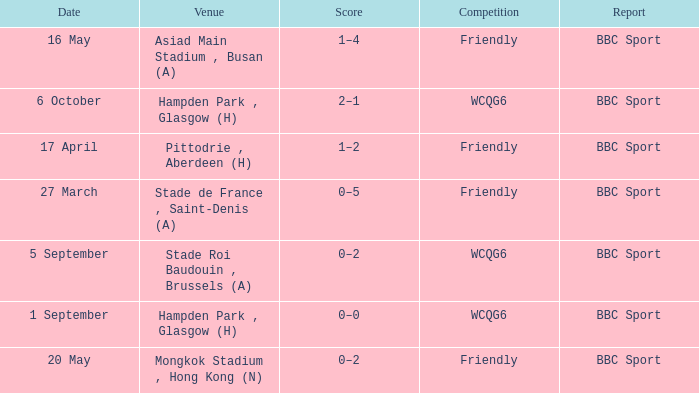Who reported the game on 6 october? BBC Sport. 